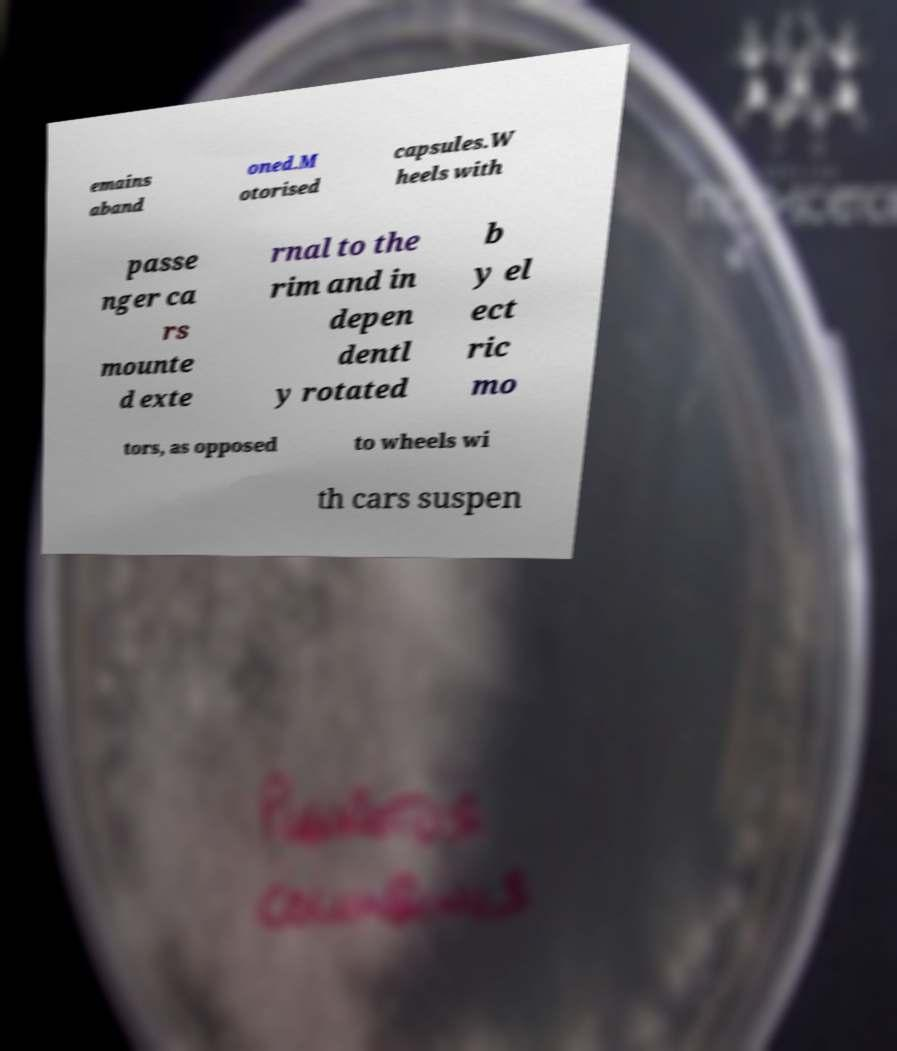Can you accurately transcribe the text from the provided image for me? emains aband oned.M otorised capsules.W heels with passe nger ca rs mounte d exte rnal to the rim and in depen dentl y rotated b y el ect ric mo tors, as opposed to wheels wi th cars suspen 